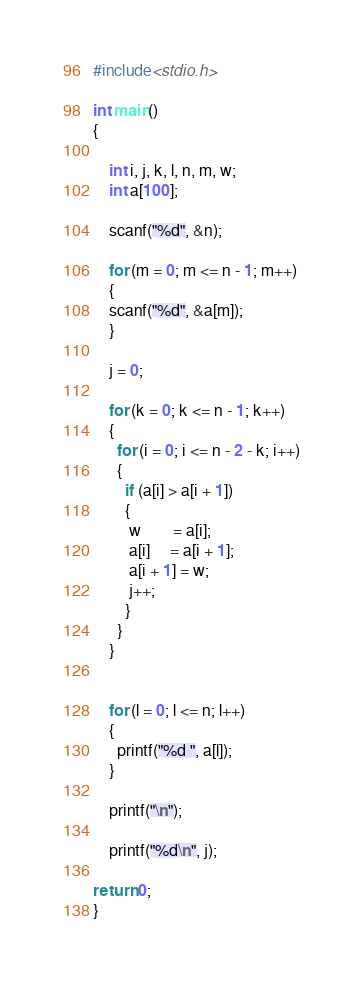Convert code to text. <code><loc_0><loc_0><loc_500><loc_500><_C_>#include<stdio.h>

int main()
{

    int i, j, k, l, n, m, w;
    int a[100];

    scanf("%d", &n);

    for (m = 0; m <= n - 1; m++)
    {
    scanf("%d", &a[m]);
    }

    j = 0;

    for (k = 0; k <= n - 1; k++)
    {
      for (i = 0; i <= n - 2 - k; i++)
      {
        if (a[i] > a[i + 1])
        {
         w        = a[i];
         a[i]     = a[i + 1];
         a[i + 1] = w;
         j++;
        }
      }
    }


    for (l = 0; l <= n; l++)
    {
      printf("%d ", a[l]);
    }

    printf("\n");

    printf("%d\n", j);

return 0;
}</code> 